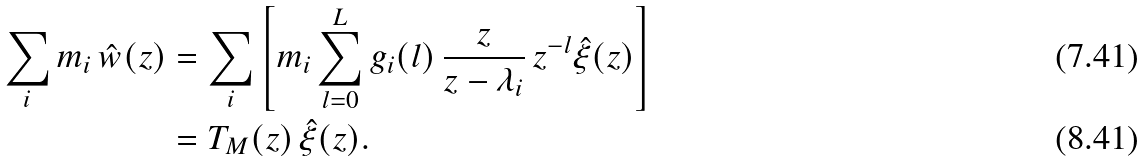Convert formula to latex. <formula><loc_0><loc_0><loc_500><loc_500>\sum _ { i } m _ { i } \, \hat { w } ( z ) & = \sum _ { i } \left [ m _ { i } \sum _ { l = 0 } ^ { L } g _ { i } ( l ) \, \frac { z } { z - \lambda _ { i } } \, z ^ { - l } \hat { \xi } ( z ) \right ] \\ & = T _ { M } ( z ) \, \hat { \xi } ( z ) .</formula> 